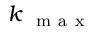Convert formula to latex. <formula><loc_0><loc_0><loc_500><loc_500>k _ { \mathrm { m a x } }</formula> 